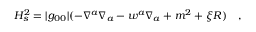<formula> <loc_0><loc_0><loc_500><loc_500>H _ { s } ^ { 2 } = | g _ { 0 0 } | ( - \nabla ^ { a } \nabla _ { a } - w ^ { a } \nabla _ { a } + m ^ { 2 } + \xi R ) ,</formula> 